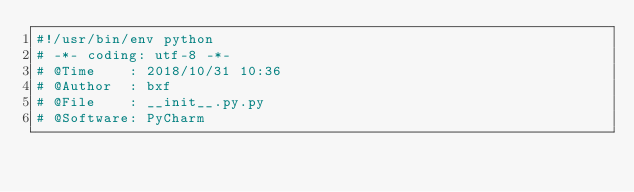<code> <loc_0><loc_0><loc_500><loc_500><_Python_>#!/usr/bin/env python
# -*- coding: utf-8 -*-
# @Time    : 2018/10/31 10:36
# @Author  : bxf
# @File    : __init__.py.py
# @Software: PyCharm
</code> 